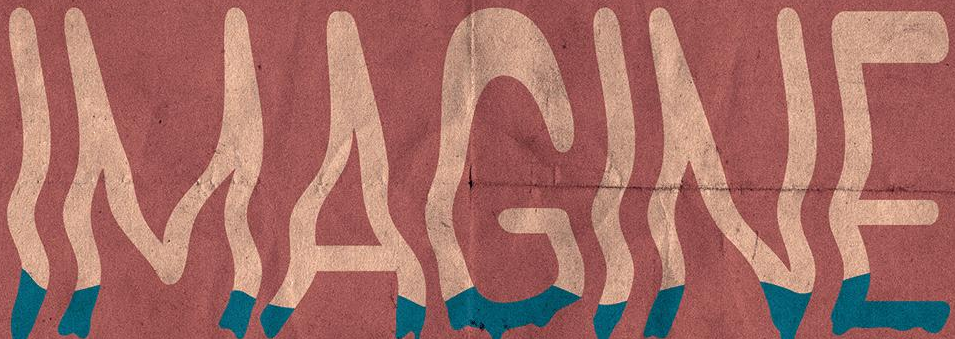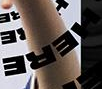What words can you see in these images in sequence, separated by a semicolon? IMAGINE; HERE 